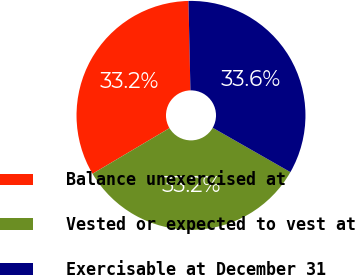<chart> <loc_0><loc_0><loc_500><loc_500><pie_chart><fcel>Balance unexercised at<fcel>Vested or expected to vest at<fcel>Exercisable at December 31<nl><fcel>33.17%<fcel>33.23%<fcel>33.61%<nl></chart> 